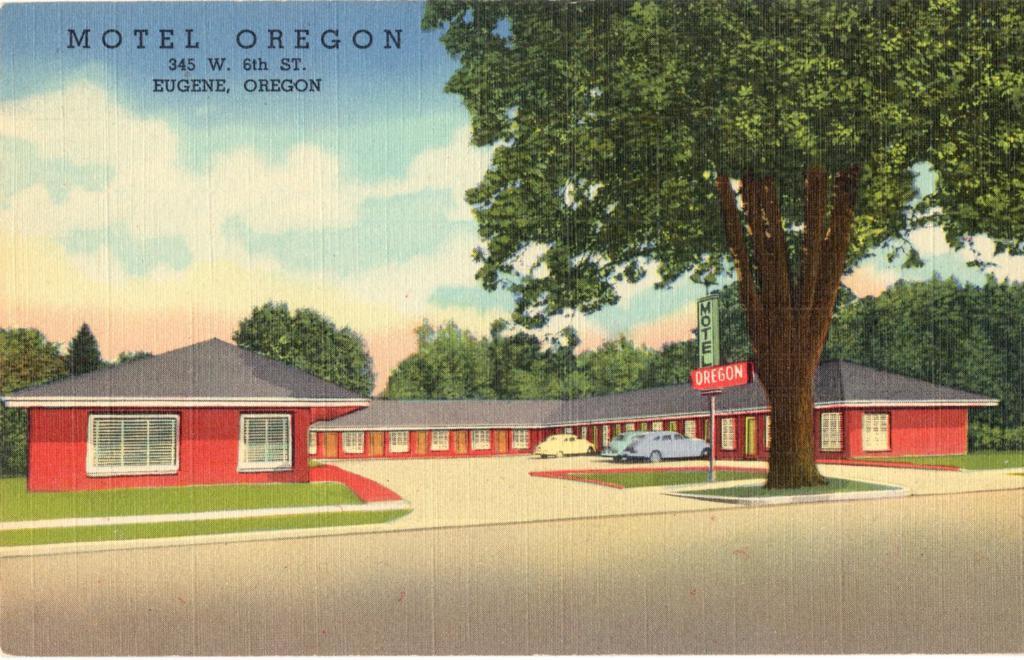Can you describe this image briefly? In this image I can see photography of the house. In-front of the house I can see the vehicles, boards and the tree. In the background I can see many trees, clouds and the sky. 